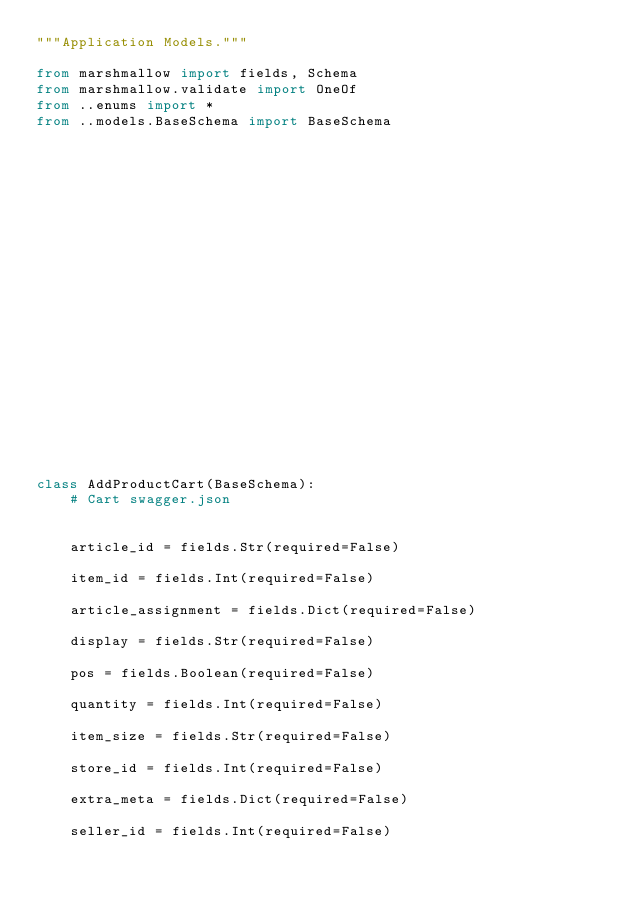Convert code to text. <code><loc_0><loc_0><loc_500><loc_500><_Python_>"""Application Models."""

from marshmallow import fields, Schema
from marshmallow.validate import OneOf
from ..enums import *
from ..models.BaseSchema import BaseSchema






















class AddProductCart(BaseSchema):
    # Cart swagger.json

    
    article_id = fields.Str(required=False)
    
    item_id = fields.Int(required=False)
    
    article_assignment = fields.Dict(required=False)
    
    display = fields.Str(required=False)
    
    pos = fields.Boolean(required=False)
    
    quantity = fields.Int(required=False)
    
    item_size = fields.Str(required=False)
    
    store_id = fields.Int(required=False)
    
    extra_meta = fields.Dict(required=False)
    
    seller_id = fields.Int(required=False)
    

</code> 